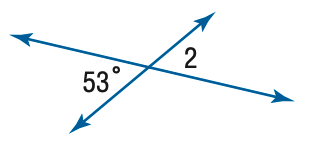Question: Find the measure of \angle 2.
Choices:
A. 53
B. 63
C. 73
D. 83
Answer with the letter. Answer: A 